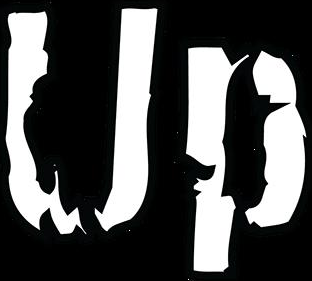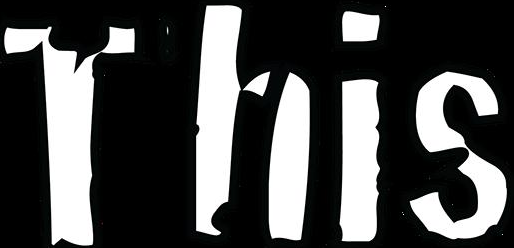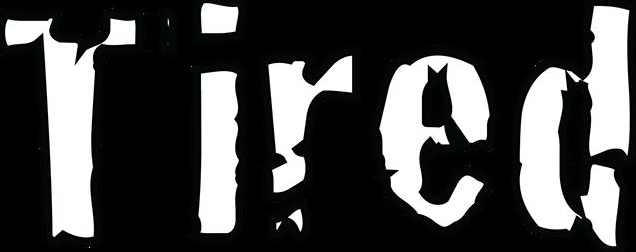Read the text from these images in sequence, separated by a semicolon. Up; This; Tired 